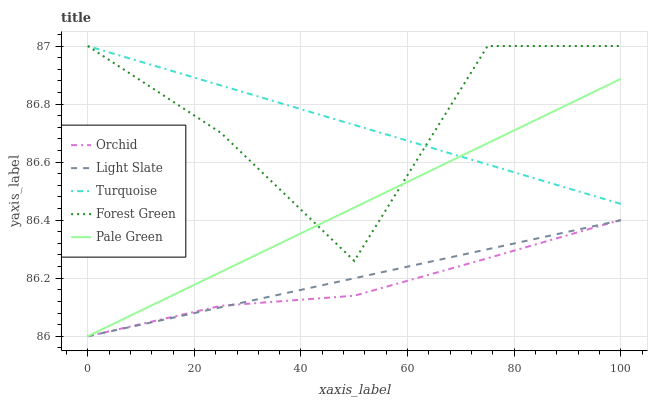Does Orchid have the minimum area under the curve?
Answer yes or no. Yes. Does Forest Green have the maximum area under the curve?
Answer yes or no. Yes. Does Turquoise have the minimum area under the curve?
Answer yes or no. No. Does Turquoise have the maximum area under the curve?
Answer yes or no. No. Is Pale Green the smoothest?
Answer yes or no. Yes. Is Forest Green the roughest?
Answer yes or no. Yes. Is Turquoise the smoothest?
Answer yes or no. No. Is Turquoise the roughest?
Answer yes or no. No. Does Light Slate have the lowest value?
Answer yes or no. Yes. Does Turquoise have the lowest value?
Answer yes or no. No. Does Forest Green have the highest value?
Answer yes or no. Yes. Does Pale Green have the highest value?
Answer yes or no. No. Is Light Slate less than Forest Green?
Answer yes or no. Yes. Is Forest Green greater than Orchid?
Answer yes or no. Yes. Does Pale Green intersect Forest Green?
Answer yes or no. Yes. Is Pale Green less than Forest Green?
Answer yes or no. No. Is Pale Green greater than Forest Green?
Answer yes or no. No. Does Light Slate intersect Forest Green?
Answer yes or no. No. 